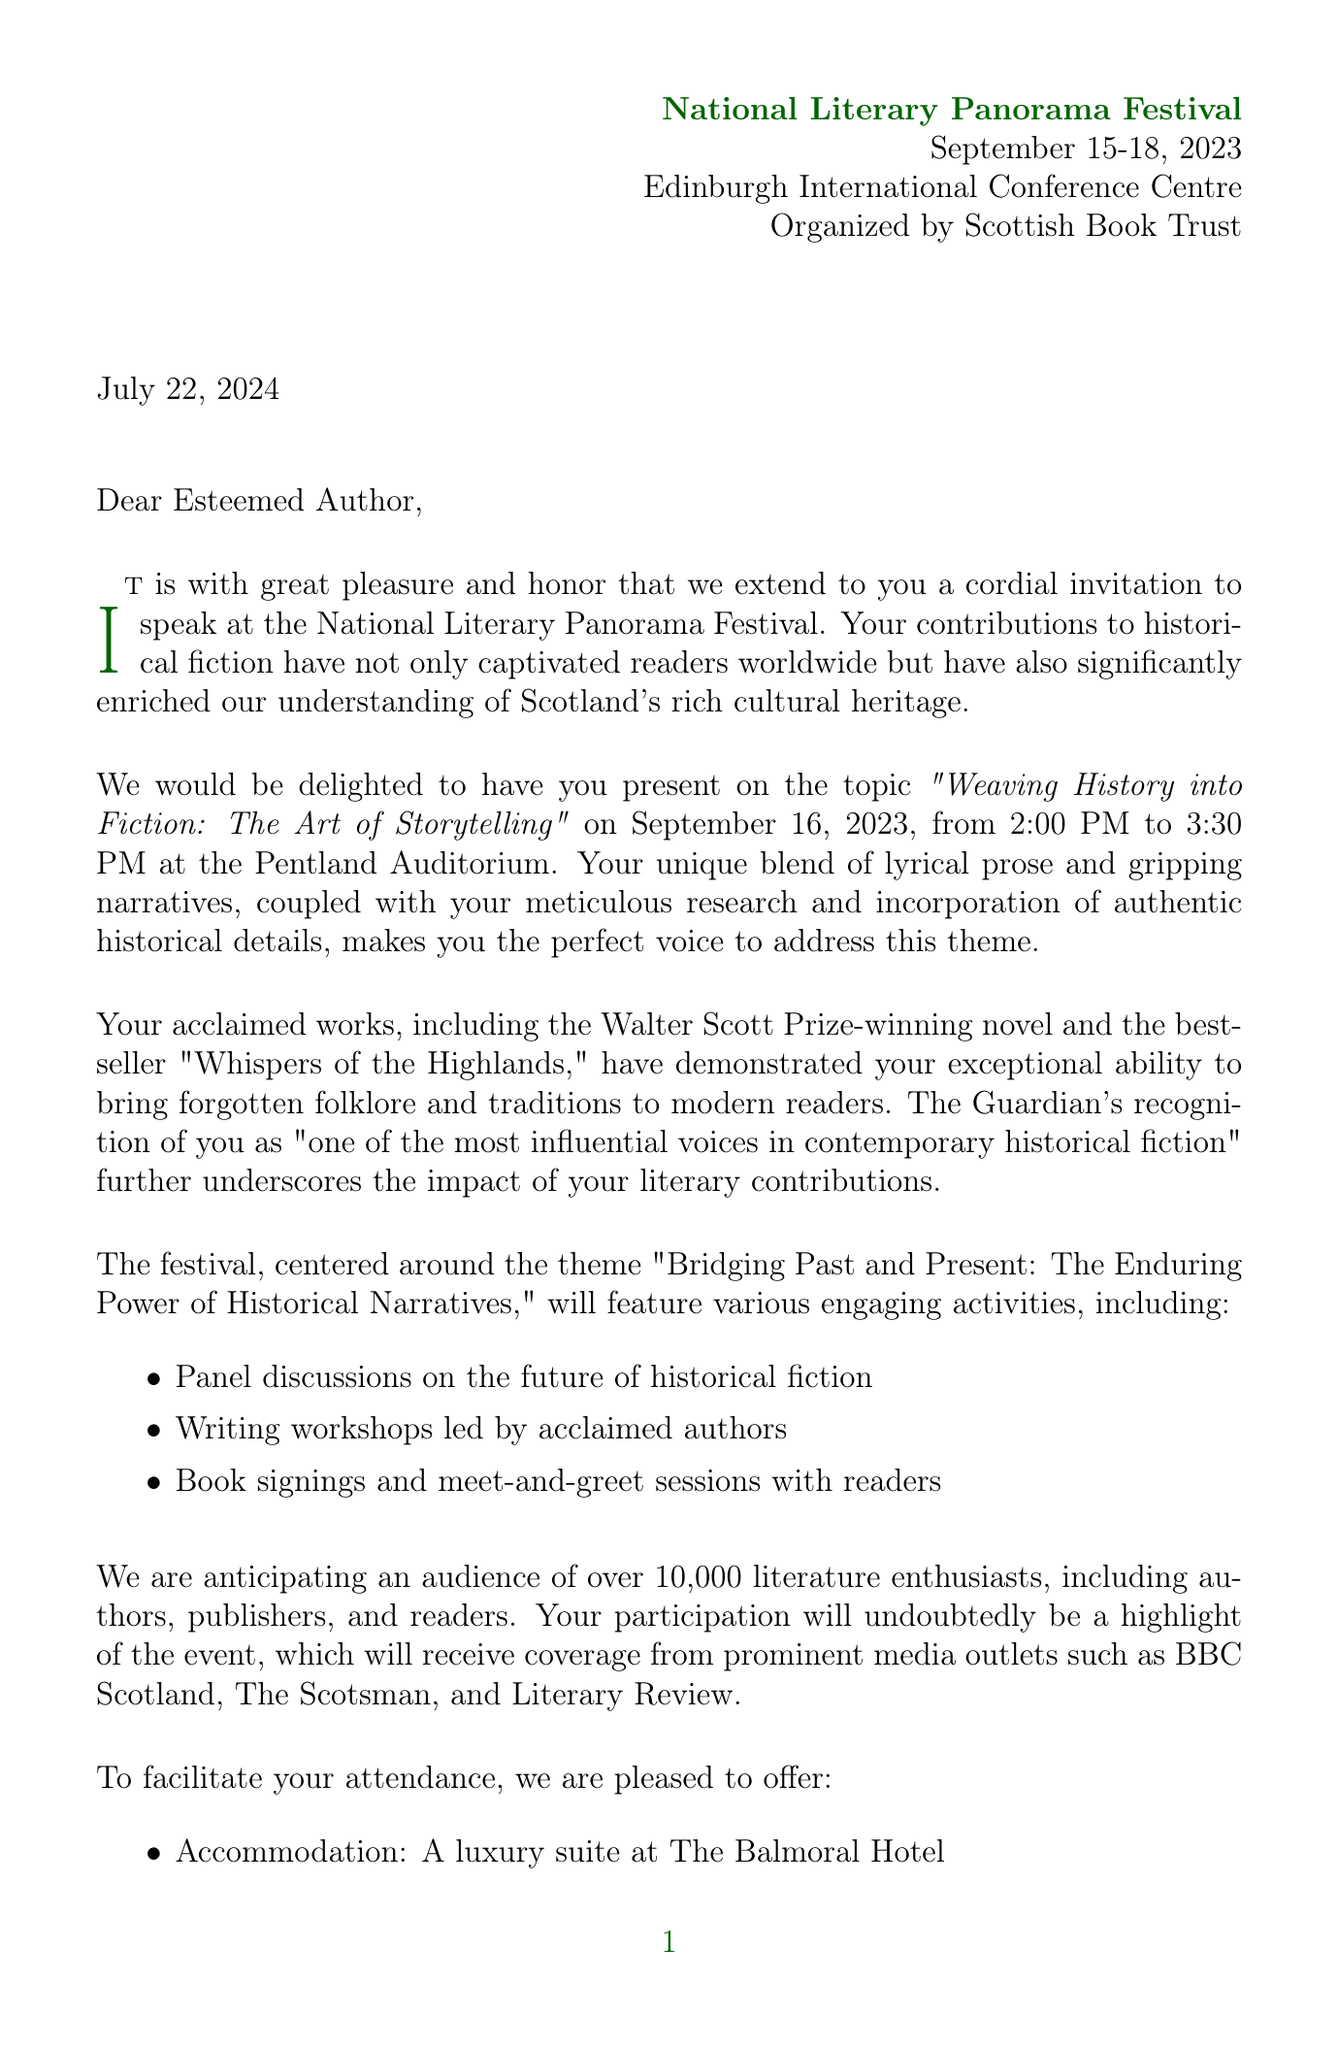What is the name of the festival? The name is mentioned at the beginning of the document.
Answer: National Literary Panorama Festival What are the festival dates? The dates are explicitly stated in the document.
Answer: September 15-18, 2023 Who is organizing the festival? The organizer's name is provided in the document.
Answer: Scottish Book Trust What is the author's bestselling novel? The title of the bestselling novel is stated.
Answer: Whispers of the Highlands What topic will the author speak on? The topic is specified in the speaking engagement section.
Answer: Weaving History into Fiction: The Art of Storytelling What is the expected audience size? The document mentions the anticipated audience.
Answer: Over 10,000 literature enthusiasts What is the speaking fee offered to the author? The honorarium is mentioned under invitation details.
Answer: £5,000 speaking fee What type of accommodations will be provided? The type of accommodation is detailed in the invitation.
Answer: Luxury suite at The Balmoral Hotel What is the theme of the festival? The theme is mentioned clearly in the document.
Answer: Bridging Past and Present: The Enduring Power of Historical Narratives 